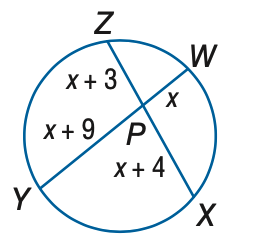Question: Find x. Assume that segments that appear to be tangent are tangent.
Choices:
A. 5
B. 6
C. 8
D. 9
Answer with the letter. Answer: B 